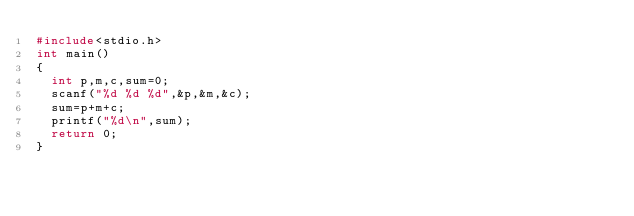Convert code to text. <code><loc_0><loc_0><loc_500><loc_500><_C_>#include<stdio.h>
int main()
{
  int p,m,c,sum=0;
  scanf("%d %d %d",&p,&m,&c);
  sum=p+m+c;
  printf("%d\n",sum);
  return 0;
}

</code> 